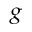Convert formula to latex. <formula><loc_0><loc_0><loc_500><loc_500>_ { g }</formula> 